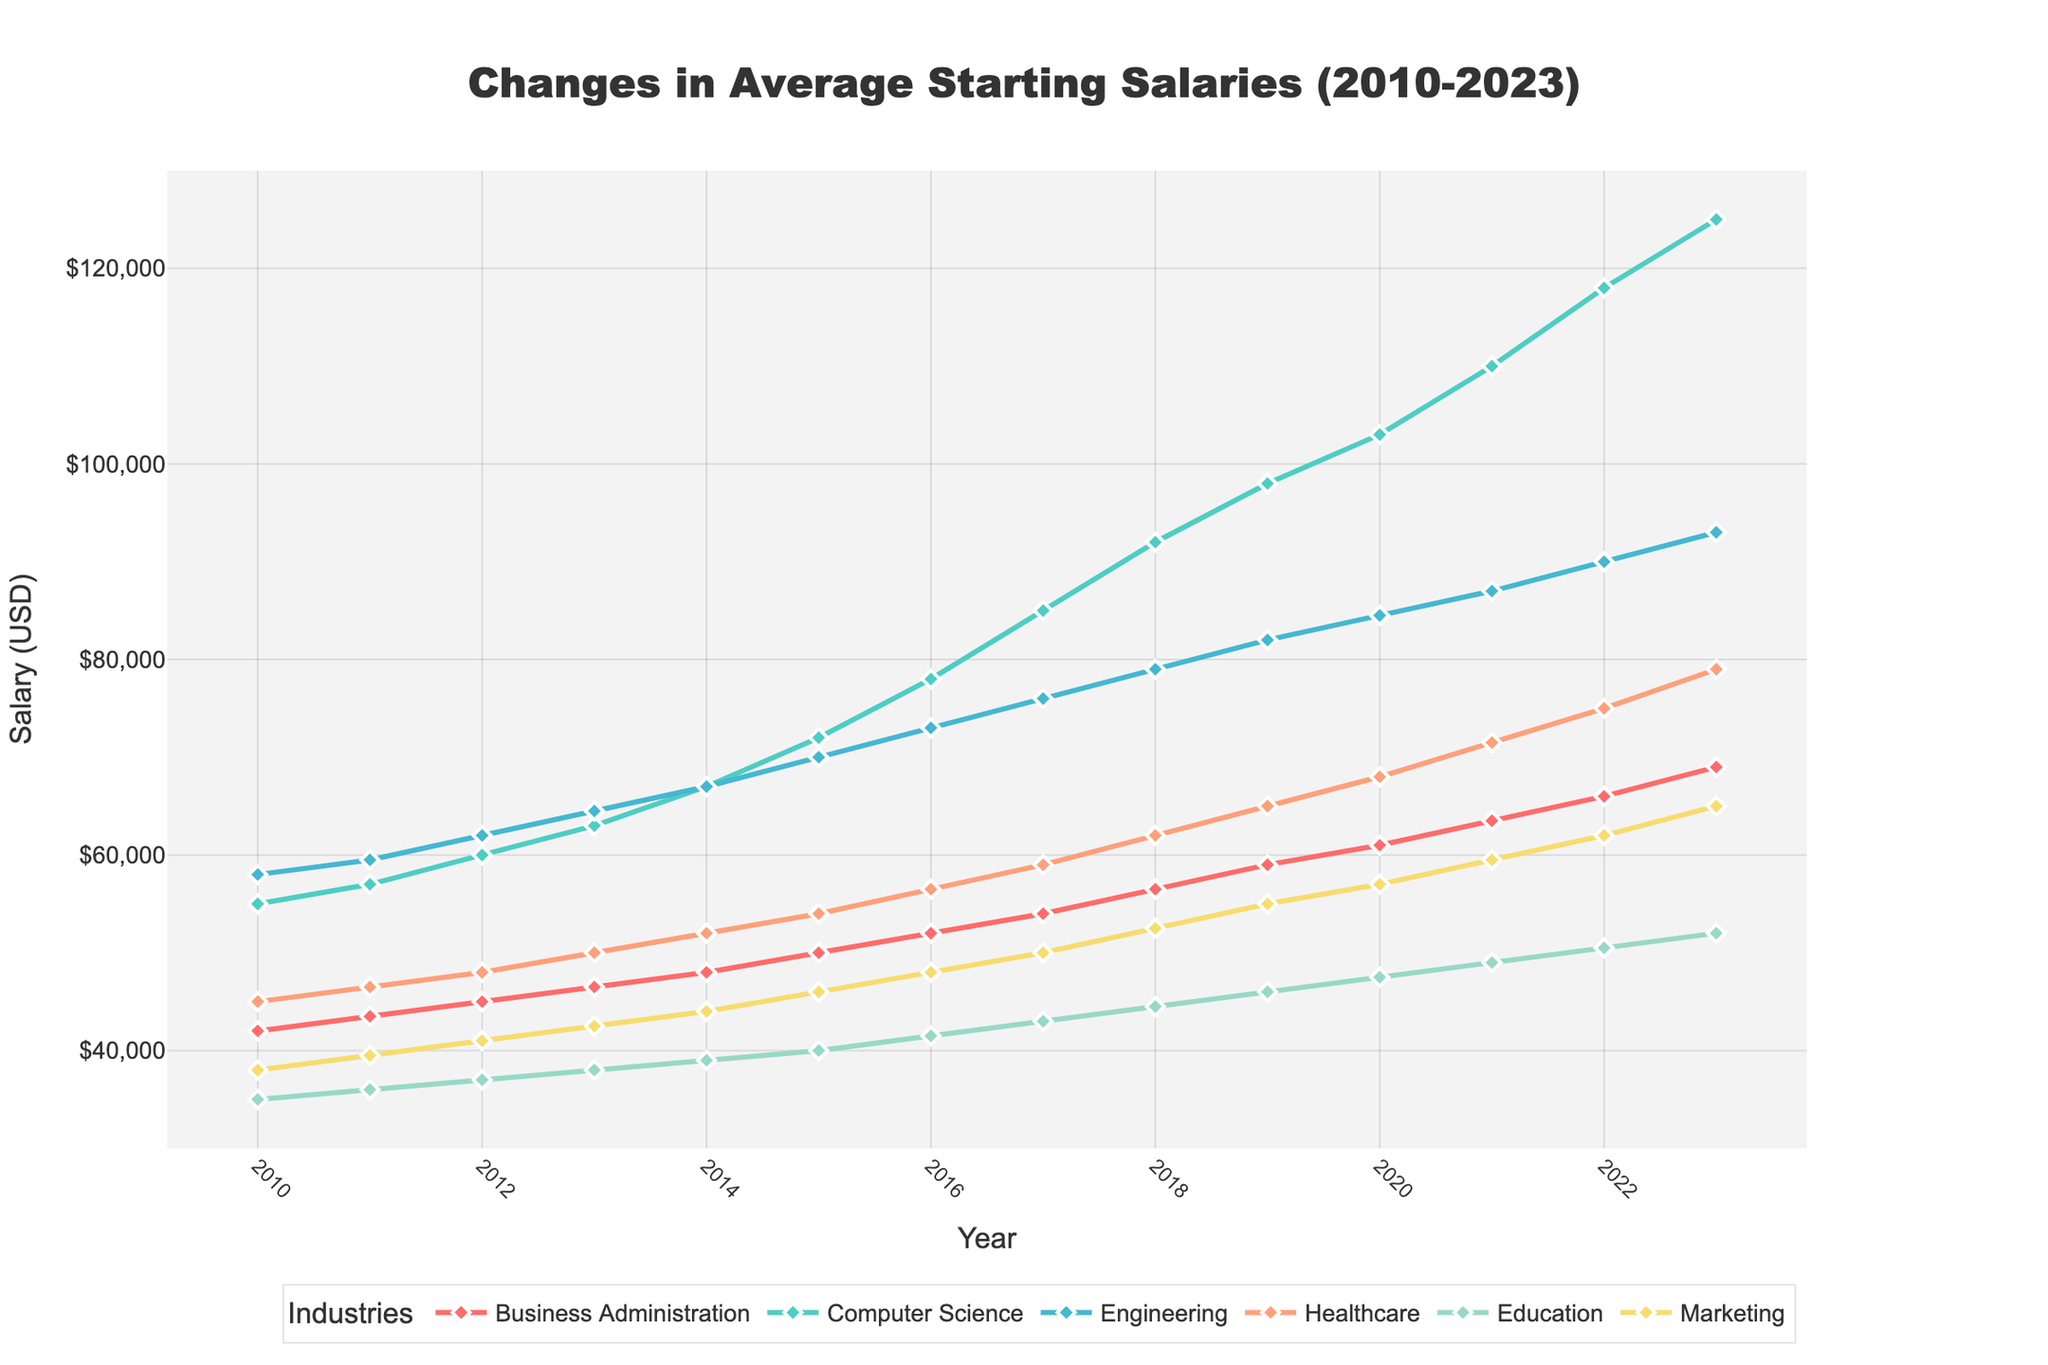What is the highest average starting salary for Computer Science in the given timeframe? Look for the highest point on the line representing Computer Science. According to the visual data, the highest average starting salary is in 2023.
Answer: $125,000 Which industry had the smallest average starting salary in 2010, and what was the amount? Locate the year 2010 and look for the lowest value among all lines. Education had the smallest average starting salary in 2010.
Answer: $35,000 How much did the starting salary for Marketing increase from 2010 to 2023? Identify the starting salary for Marketing in 2010 and 2023, then subtract the former from the latter: $65,000 - $38,000.
Answer: $27,000 In what year did Healthcare starting salaries first surpass $60,000? Find the Healthcare line and track the years where the salary crosses the $60,000 threshold. The first instance is in 2018.
Answer: 2018 What is the trend in average starting salaries for Engineering from 2010 to 2023? Observe the line for Engineering from 2010 to 2023. The trend shows a consistent increase every year.
Answer: Increasing Which industry had the largest percentage increase in starting salary from 2010 to 2023, and what was the percentage? Calculate the percentage increase for each industry: (Final Value - Initial Value) / Initial Value * 100%. The Computer Science increase is the largest: (125,000 - 55,000) / 55,000 * 100%.
Answer: Computer Science, 127.27% Which industry started with a lower average salary than Healthcare in 2010 but ended with a higher average salary in 2023? Compare initial and final values while considering Healthcare's starting and ending values. Marketing is one such industry moving from $38,000 to $65,000.
Answer: Marketing What is the average starting salary for Business Administration across all years? Add the Business Administration values from 2010 to 2023 and divide by the number of years: (42000+43500+45000+46500+48000+50000+52000+54000+56500+59000+61000+63500+66000+69000) / 14.
Answer: $53,000 Compare the starting salary trends of Education and Marketing. Which one grew faster? Observe the slope of the lines for Education and Marketing. Calculate the difference from 2010 to 2023 for each and compare. Education grows from $35,000 to $52,000, Marketing from $38,000 to $65,000.
Answer: Marketing What was the difference in starting salary for Engineering between 2020 and 2023? Subtract the 2020 value from the 2023 value for Engineering: $93,000 - $84,500.
Answer: $8,500 Which industry had the least variation in starting salaries from 2010 to 2023? Compare the range (max - min) for each industry. Education varies the least from $35,000 to $52,000.
Answer: Education 